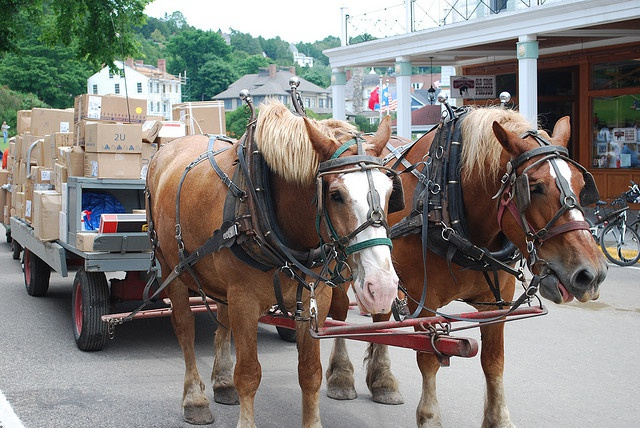Describe the objects in this image and their specific colors. I can see horse in black, maroon, and gray tones, horse in black, maroon, and gray tones, and bicycle in black, gray, darkgray, and blue tones in this image. 